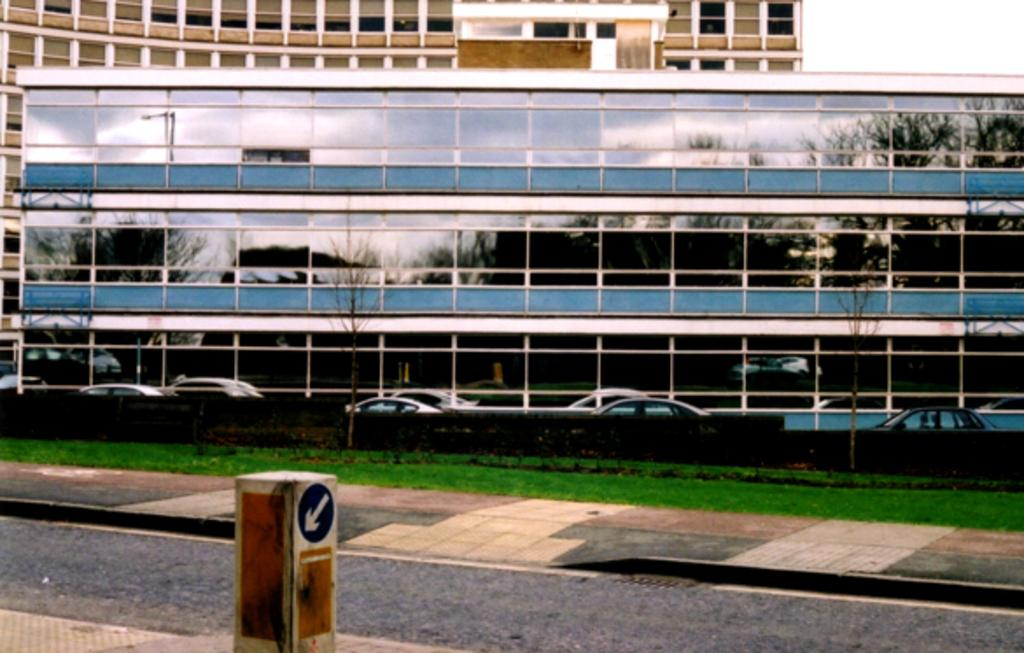What type of structures can be seen in the image? There are buildings in the image. What else is present in the image besides buildings? There are vehicles and a pillar visible in the image. Can you describe a unique feature of one of the buildings? There is a reflection of trees on a building in the image. What can be seen in the background of the image? The sky is visible in the background of the image. What type of horn can be heard coming from the robin in the image? There is no robin present in the image, and therefore no horn can be heard. What is the base of the pillar made of in the image? The provided facts do not mention the material of the pillar, so it cannot be determined from the image. 